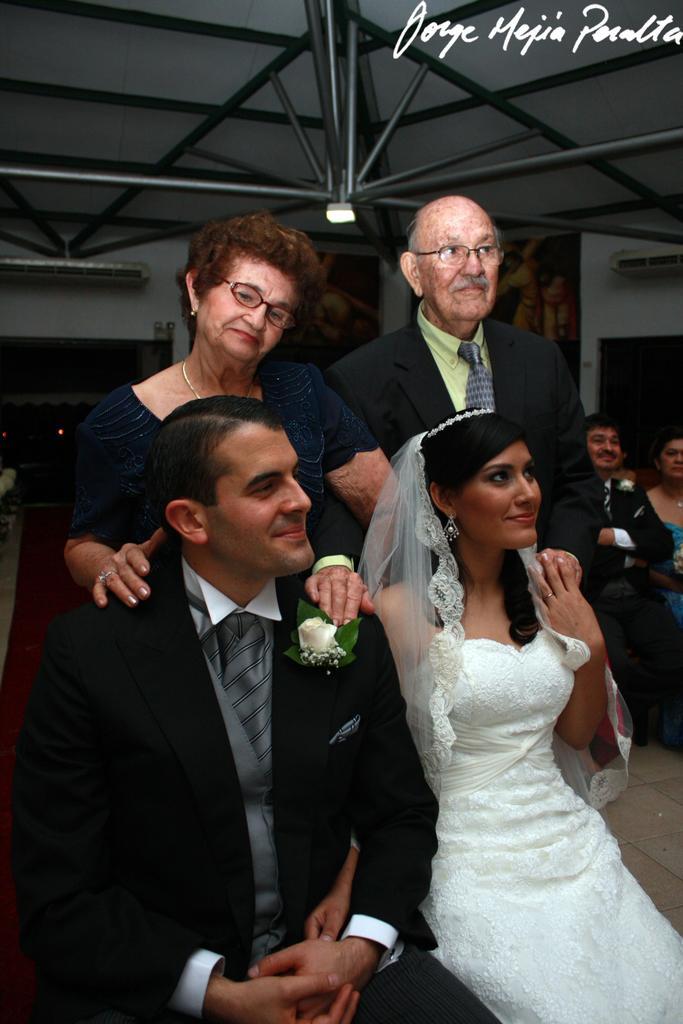In one or two sentences, can you explain what this image depicts? In the image we can see there are people sitting and two of them are standing, they are wearing clothes and some of them are wearing spectacles and they are smiling. Here we can see the roof, metal rods and the floor. The background is slightly dark and on the top right, we can see the watermark. 